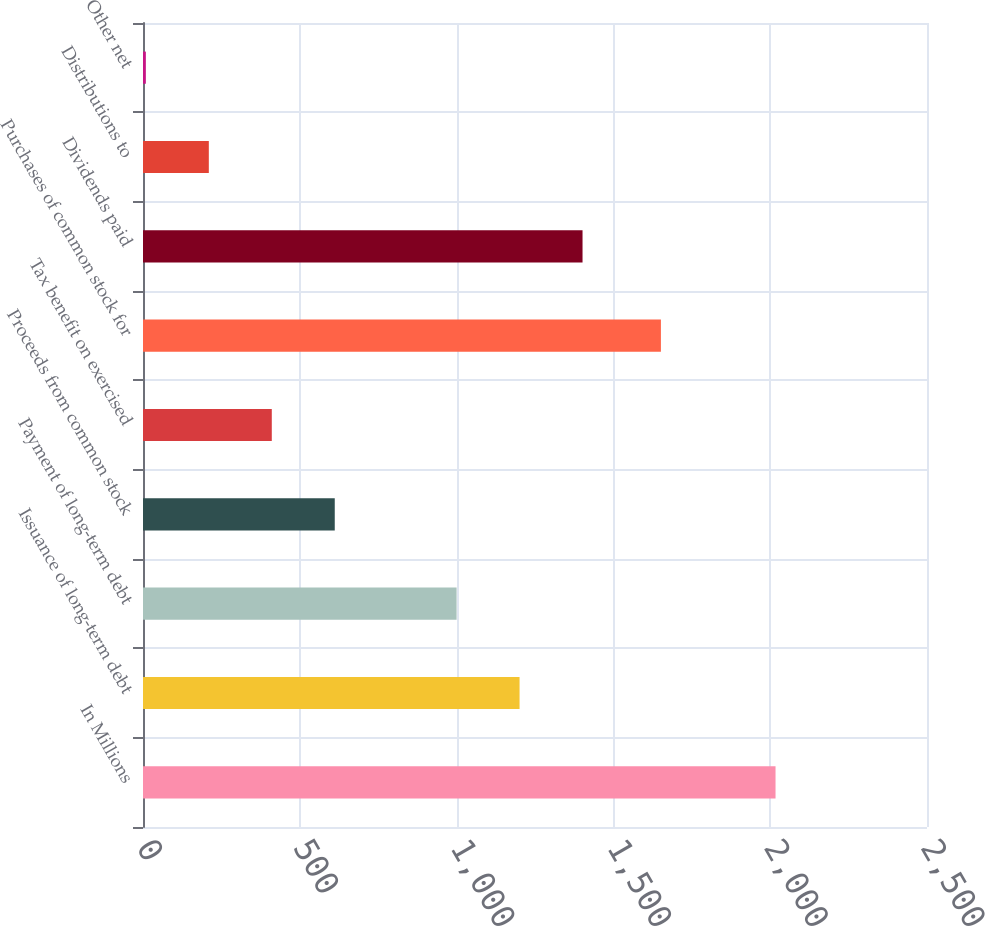<chart> <loc_0><loc_0><loc_500><loc_500><bar_chart><fcel>In Millions<fcel>Issuance of long-term debt<fcel>Payment of long-term debt<fcel>Proceeds from common stock<fcel>Tax benefit on exercised<fcel>Purchases of common stock for<fcel>Dividends paid<fcel>Distributions to<fcel>Other net<nl><fcel>2017<fcel>1200.79<fcel>1000<fcel>611.47<fcel>410.68<fcel>1651.5<fcel>1401.58<fcel>209.89<fcel>9.1<nl></chart> 